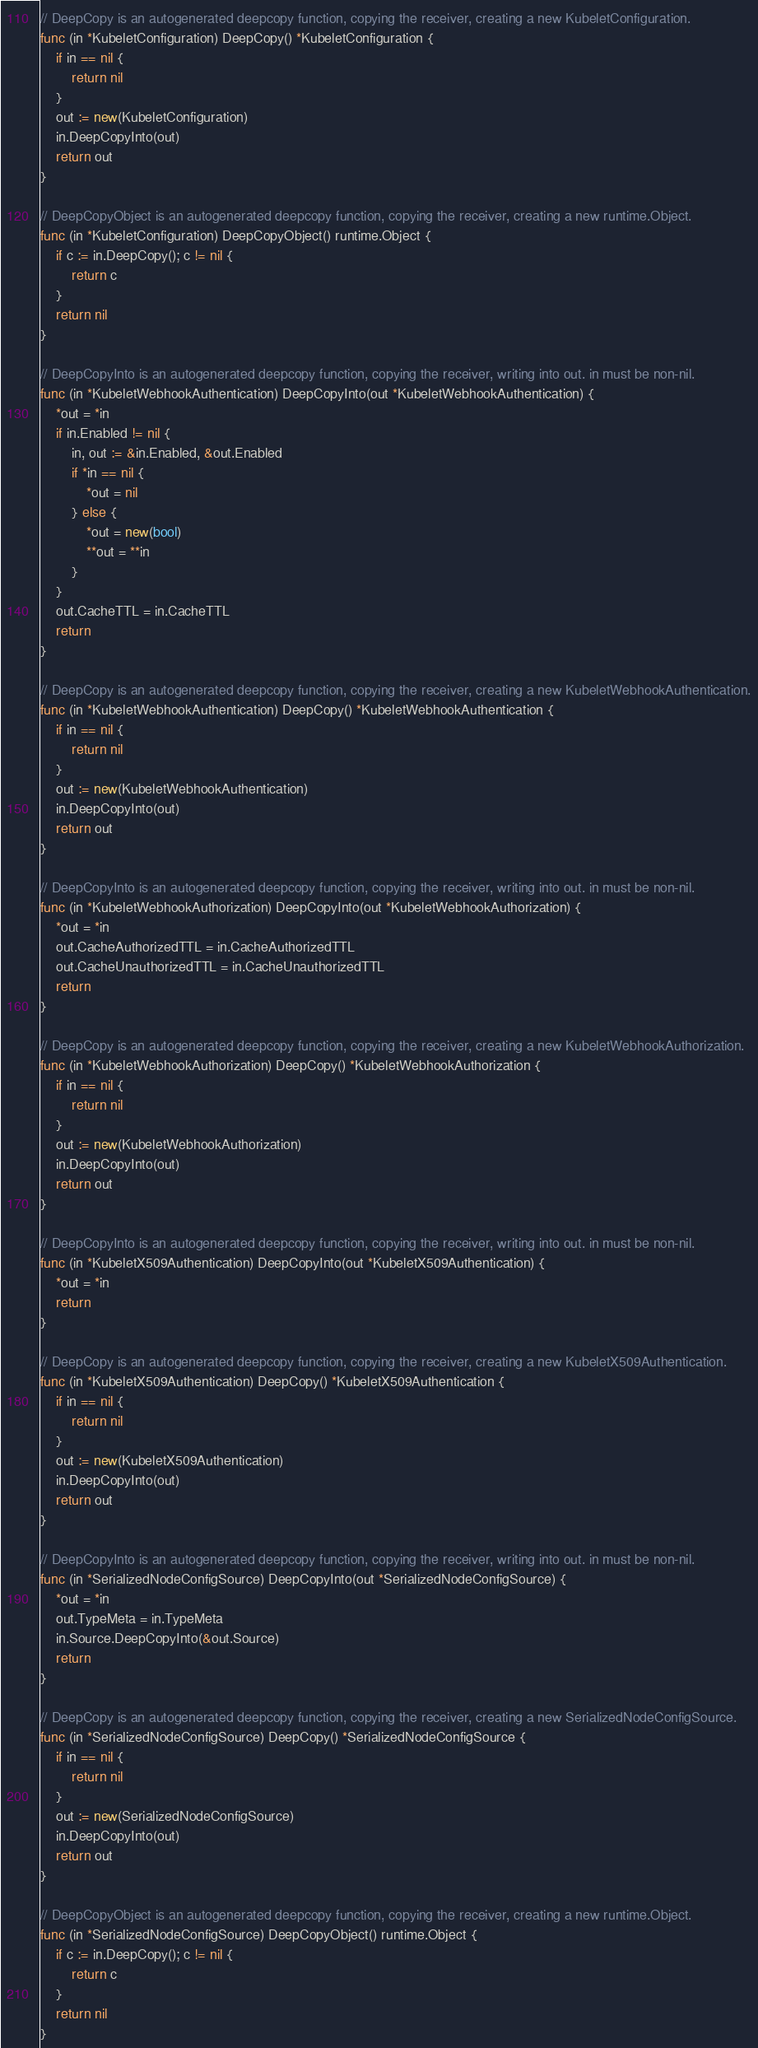<code> <loc_0><loc_0><loc_500><loc_500><_Go_>// DeepCopy is an autogenerated deepcopy function, copying the receiver, creating a new KubeletConfiguration.
func (in *KubeletConfiguration) DeepCopy() *KubeletConfiguration {
	if in == nil {
		return nil
	}
	out := new(KubeletConfiguration)
	in.DeepCopyInto(out)
	return out
}

// DeepCopyObject is an autogenerated deepcopy function, copying the receiver, creating a new runtime.Object.
func (in *KubeletConfiguration) DeepCopyObject() runtime.Object {
	if c := in.DeepCopy(); c != nil {
		return c
	}
	return nil
}

// DeepCopyInto is an autogenerated deepcopy function, copying the receiver, writing into out. in must be non-nil.
func (in *KubeletWebhookAuthentication) DeepCopyInto(out *KubeletWebhookAuthentication) {
	*out = *in
	if in.Enabled != nil {
		in, out := &in.Enabled, &out.Enabled
		if *in == nil {
			*out = nil
		} else {
			*out = new(bool)
			**out = **in
		}
	}
	out.CacheTTL = in.CacheTTL
	return
}

// DeepCopy is an autogenerated deepcopy function, copying the receiver, creating a new KubeletWebhookAuthentication.
func (in *KubeletWebhookAuthentication) DeepCopy() *KubeletWebhookAuthentication {
	if in == nil {
		return nil
	}
	out := new(KubeletWebhookAuthentication)
	in.DeepCopyInto(out)
	return out
}

// DeepCopyInto is an autogenerated deepcopy function, copying the receiver, writing into out. in must be non-nil.
func (in *KubeletWebhookAuthorization) DeepCopyInto(out *KubeletWebhookAuthorization) {
	*out = *in
	out.CacheAuthorizedTTL = in.CacheAuthorizedTTL
	out.CacheUnauthorizedTTL = in.CacheUnauthorizedTTL
	return
}

// DeepCopy is an autogenerated deepcopy function, copying the receiver, creating a new KubeletWebhookAuthorization.
func (in *KubeletWebhookAuthorization) DeepCopy() *KubeletWebhookAuthorization {
	if in == nil {
		return nil
	}
	out := new(KubeletWebhookAuthorization)
	in.DeepCopyInto(out)
	return out
}

// DeepCopyInto is an autogenerated deepcopy function, copying the receiver, writing into out. in must be non-nil.
func (in *KubeletX509Authentication) DeepCopyInto(out *KubeletX509Authentication) {
	*out = *in
	return
}

// DeepCopy is an autogenerated deepcopy function, copying the receiver, creating a new KubeletX509Authentication.
func (in *KubeletX509Authentication) DeepCopy() *KubeletX509Authentication {
	if in == nil {
		return nil
	}
	out := new(KubeletX509Authentication)
	in.DeepCopyInto(out)
	return out
}

// DeepCopyInto is an autogenerated deepcopy function, copying the receiver, writing into out. in must be non-nil.
func (in *SerializedNodeConfigSource) DeepCopyInto(out *SerializedNodeConfigSource) {
	*out = *in
	out.TypeMeta = in.TypeMeta
	in.Source.DeepCopyInto(&out.Source)
	return
}

// DeepCopy is an autogenerated deepcopy function, copying the receiver, creating a new SerializedNodeConfigSource.
func (in *SerializedNodeConfigSource) DeepCopy() *SerializedNodeConfigSource {
	if in == nil {
		return nil
	}
	out := new(SerializedNodeConfigSource)
	in.DeepCopyInto(out)
	return out
}

// DeepCopyObject is an autogenerated deepcopy function, copying the receiver, creating a new runtime.Object.
func (in *SerializedNodeConfigSource) DeepCopyObject() runtime.Object {
	if c := in.DeepCopy(); c != nil {
		return c
	}
	return nil
}
</code> 